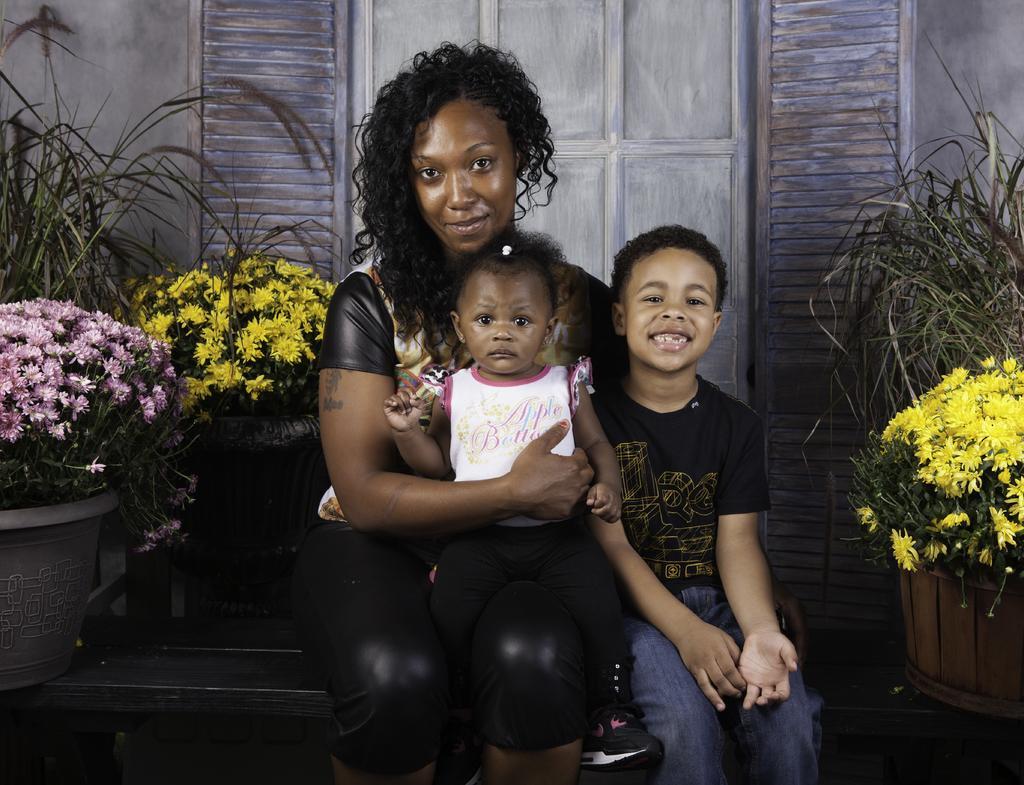Can you describe this image briefly? In this image I can see three people with different color dresses. These people are siting on the bench. To the side of these people I can see the flower pots. There are yellow and pink color flowers can be seen. In the back I can see the wooden wall. 